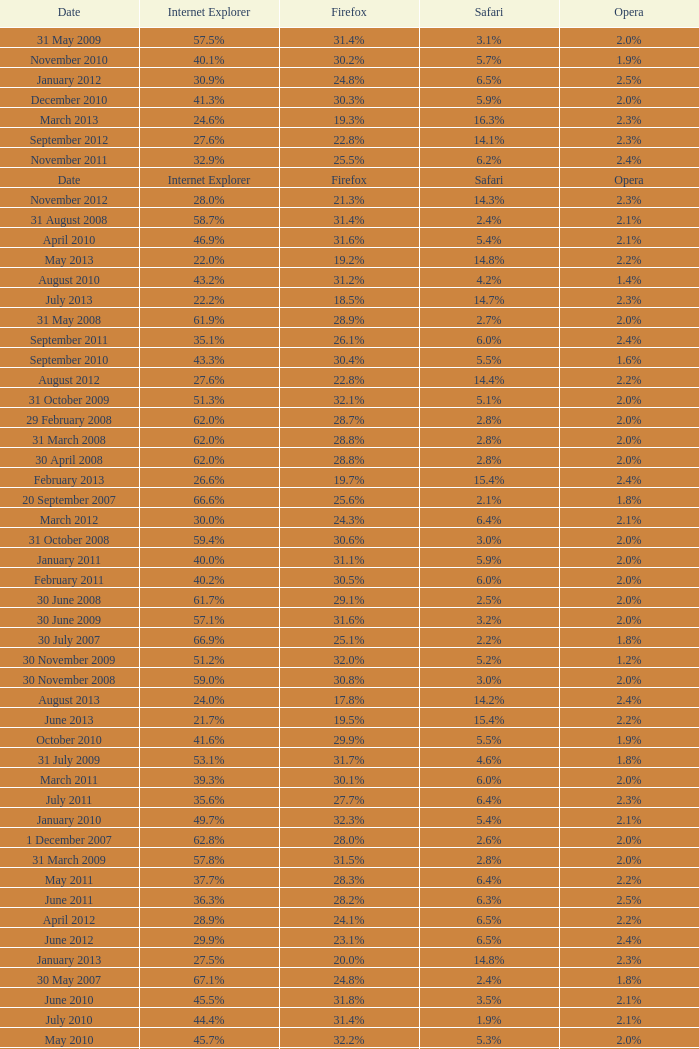What is the safari value with a 28.0% internet explorer? 14.3%. 